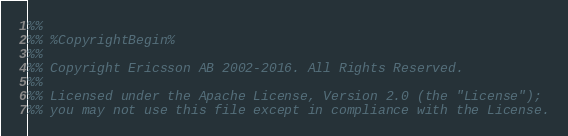<code> <loc_0><loc_0><loc_500><loc_500><_Erlang_>%%
%% %CopyrightBegin%
%% 
%% Copyright Ericsson AB 2002-2016. All Rights Reserved.
%% 
%% Licensed under the Apache License, Version 2.0 (the "License");
%% you may not use this file except in compliance with the License.</code> 